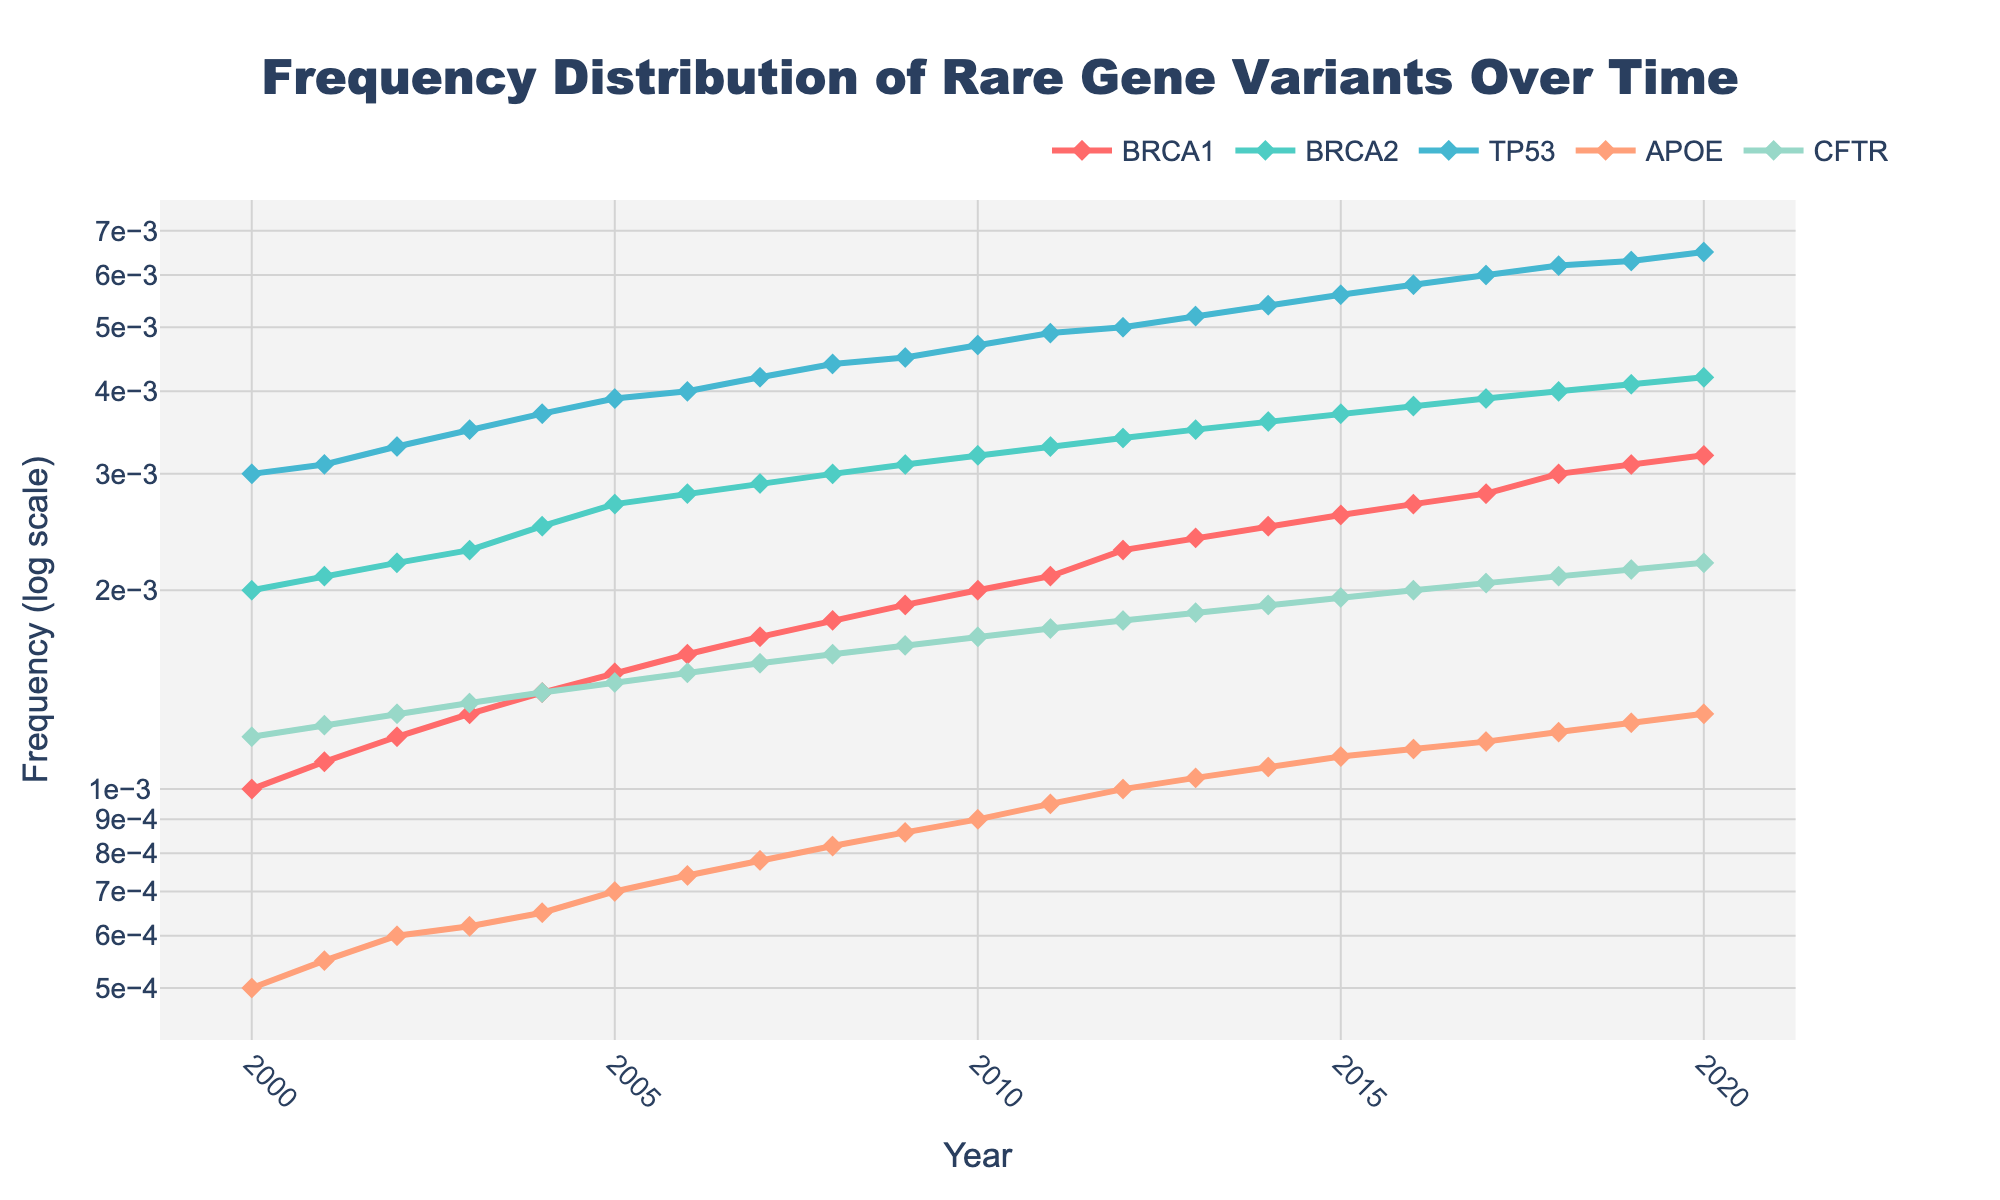What is the title of the plot? The title of the plot is usually found at the top of the figure. In this case, it reads "Frequency Distribution of Rare Gene Variants Over Time".
Answer: Frequency Distribution of Rare Gene Variants Over Time Which gene has the highest frequency increase from 2000 to 2020? By comparing the end values in 2020 with the starting values in 2000 for each gene, we see that TP53 increases from 0.003 to 0.0065, which is the highest absolute increase (0.0035).
Answer: TP53 What is the frequency of the APOE gene variant in 2010? Look at the year 2010 on the x-axis and find the value corresponding to the APOE line. It is marked at 0.0009.
Answer: 0.0009 How many data points are shown for each gene? Each gene has one data point per year from 2000 to 2020, giving a total of 21 data points per gene.
Answer: 21 What is the average frequency increase per year for the BRCA1 variant? Subtract the starting value in 2000 (0.001) from the ending value in 2020 (0.0032). Then divide by the number of years (20). (0.0032 - 0.001) / 20 = 0.00011
Answer: 0.00011 Which gene has the smallest frequency value in 2005? Compare the values all genes have in 2005. The APOE gene variant has the smallest value with 0.0007.
Answer: APOE What does the y-axis represent in the plot? The y-axis indicates the frequency of gene variants on a logarithmic scale.
Answer: Frequency (log scale) Compare the growth rate of the BRCA2 and CFTR variants across the entire period. Which shows a steeper increase? Calculate the frequency increase for BRCA2 from 0.002 to 0.0042 (0.0022), and CFTR from 0.0012 to 0.0022 (0.001). BRCA2 shows a steeper increase.
Answer: BRCA2 Which year saw the frequency of the CFTR gene variant exceed 0.001? By tracing the line for CFTR, we see that the frequency first exceeds 0.001 in 2004.
Answer: 2004 What is the pattern observed in the frequencies of BRCA1 and BRCA2 from 2000 to 2020? Examine the trends of BRCA1 and BRCA2 lines: they both show a steady and almost linear increase in frequency over the years.
Answer: Steady, linear increase 